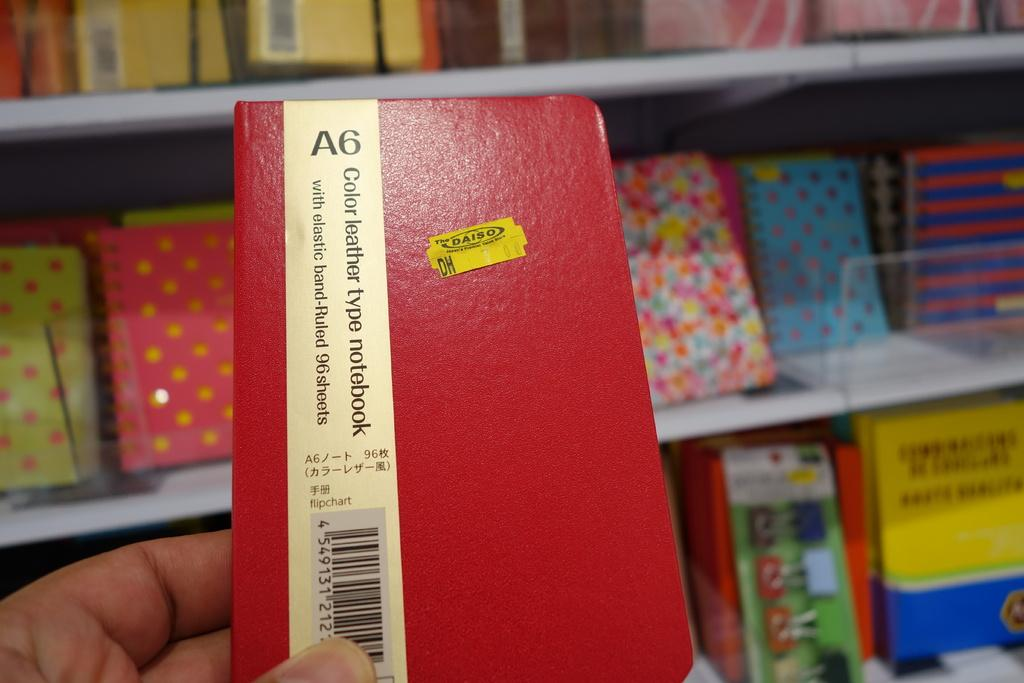Provide a one-sentence caption for the provided image. A red notebook with the A6 written along the  top and a yellow speaker. 